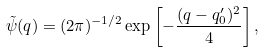Convert formula to latex. <formula><loc_0><loc_0><loc_500><loc_500>\tilde { \psi } ( q ) = ( 2 \pi ) ^ { - 1 / 2 } \exp \left [ - \frac { ( q - q _ { 0 } ^ { \prime } ) ^ { 2 } } { 4 } \right ] ,</formula> 